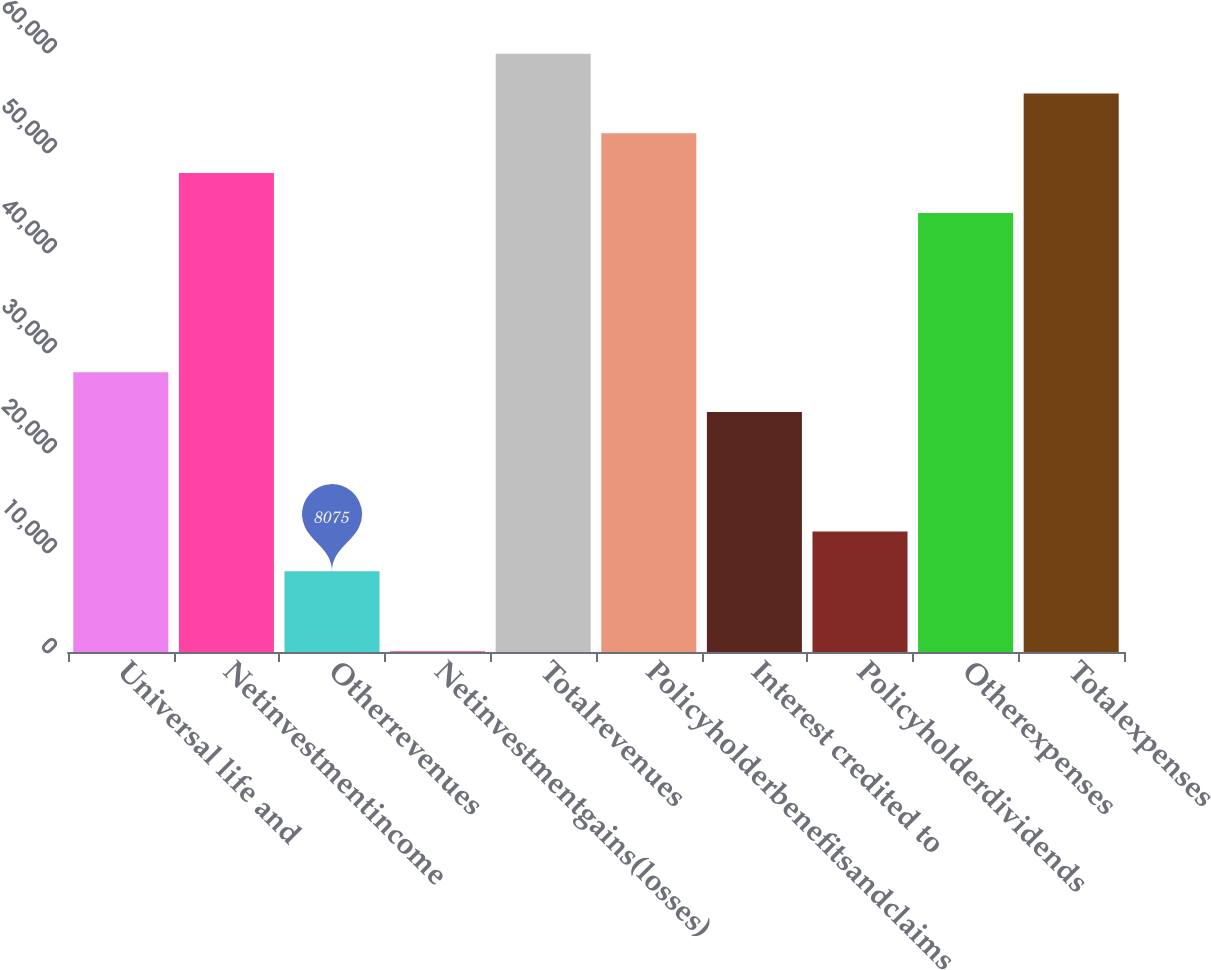Convert chart to OTSL. <chart><loc_0><loc_0><loc_500><loc_500><bar_chart><fcel>Universal life and<fcel>Netinvestmentincome<fcel>Otherrevenues<fcel>Netinvestmentgains(losses)<fcel>Totalrevenues<fcel>Policyholderbenefitsandclaims<fcel>Interest credited to<fcel>Policyholderdividends<fcel>Otherexpenses<fcel>Totalexpenses<nl><fcel>27982.5<fcel>47890<fcel>8075<fcel>112<fcel>59834.5<fcel>51871.5<fcel>24001<fcel>12056.5<fcel>43908.5<fcel>55853<nl></chart> 